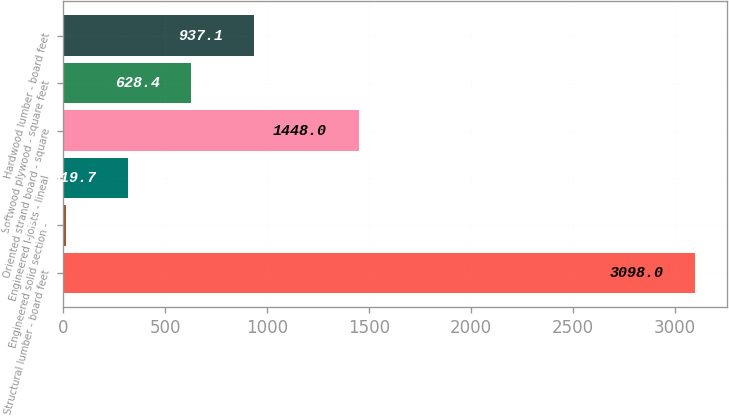<chart> <loc_0><loc_0><loc_500><loc_500><bar_chart><fcel>Structural lumber - board feet<fcel>Engineered solid section -<fcel>Engineered I-joists - lineal<fcel>Oriented strand board - square<fcel>Softwood plywood - square feet<fcel>Hardwood lumber - board feet<nl><fcel>3098<fcel>11<fcel>319.7<fcel>1448<fcel>628.4<fcel>937.1<nl></chart> 